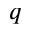Convert formula to latex. <formula><loc_0><loc_0><loc_500><loc_500>q</formula> 